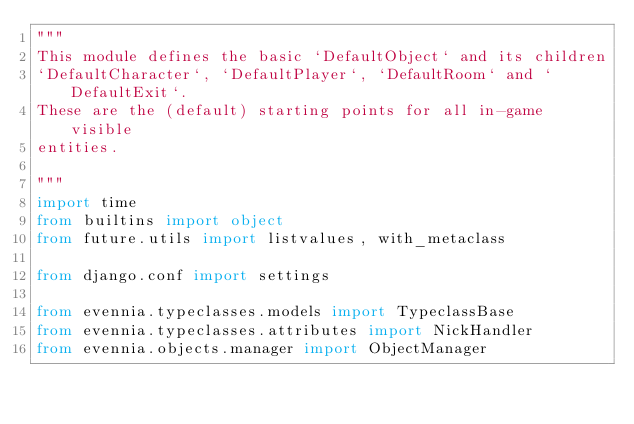Convert code to text. <code><loc_0><loc_0><loc_500><loc_500><_Python_>"""
This module defines the basic `DefaultObject` and its children
`DefaultCharacter`, `DefaultPlayer`, `DefaultRoom` and `DefaultExit`.
These are the (default) starting points for all in-game visible
entities.

"""
import time
from builtins import object
from future.utils import listvalues, with_metaclass

from django.conf import settings

from evennia.typeclasses.models import TypeclassBase
from evennia.typeclasses.attributes import NickHandler
from evennia.objects.manager import ObjectManager</code> 